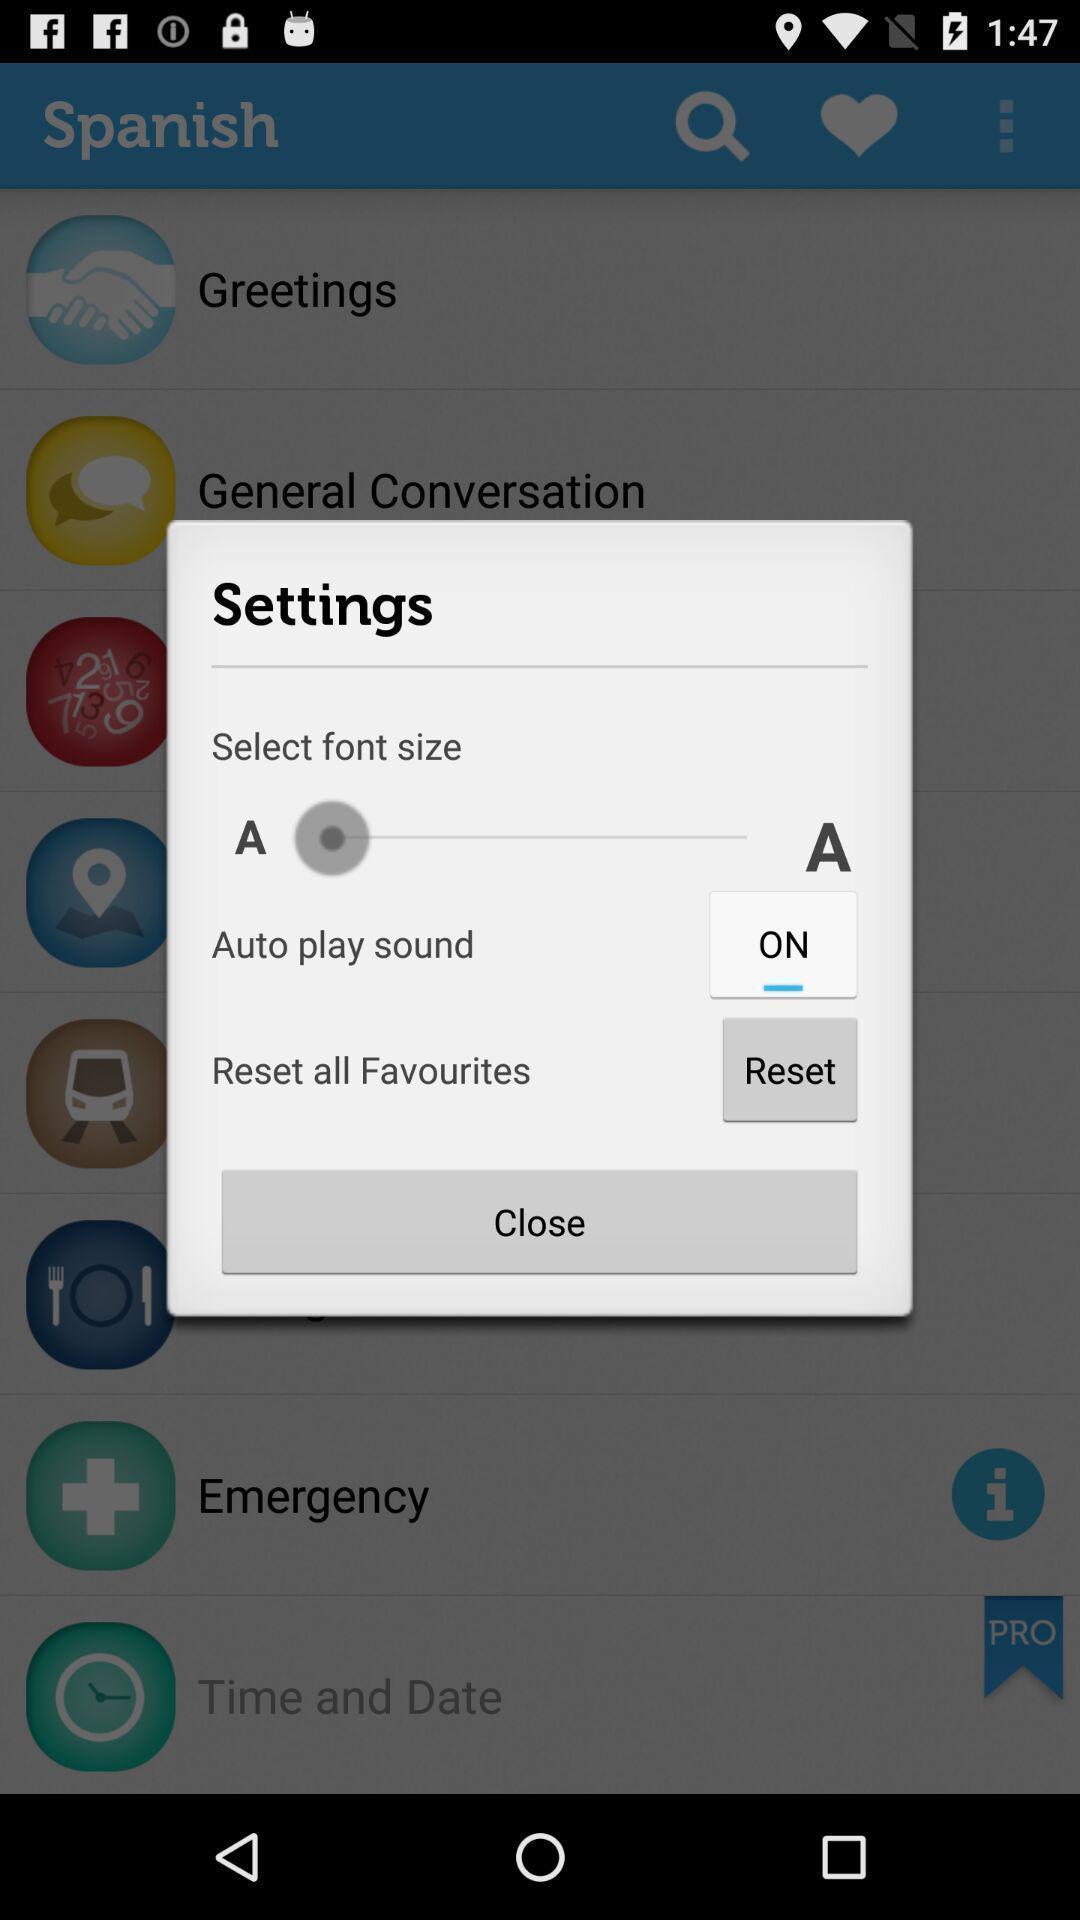Describe this image in words. Pop up showing multiple setting options on an app. 